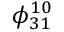<formula> <loc_0><loc_0><loc_500><loc_500>\phi _ { 3 1 } ^ { 1 0 }</formula> 